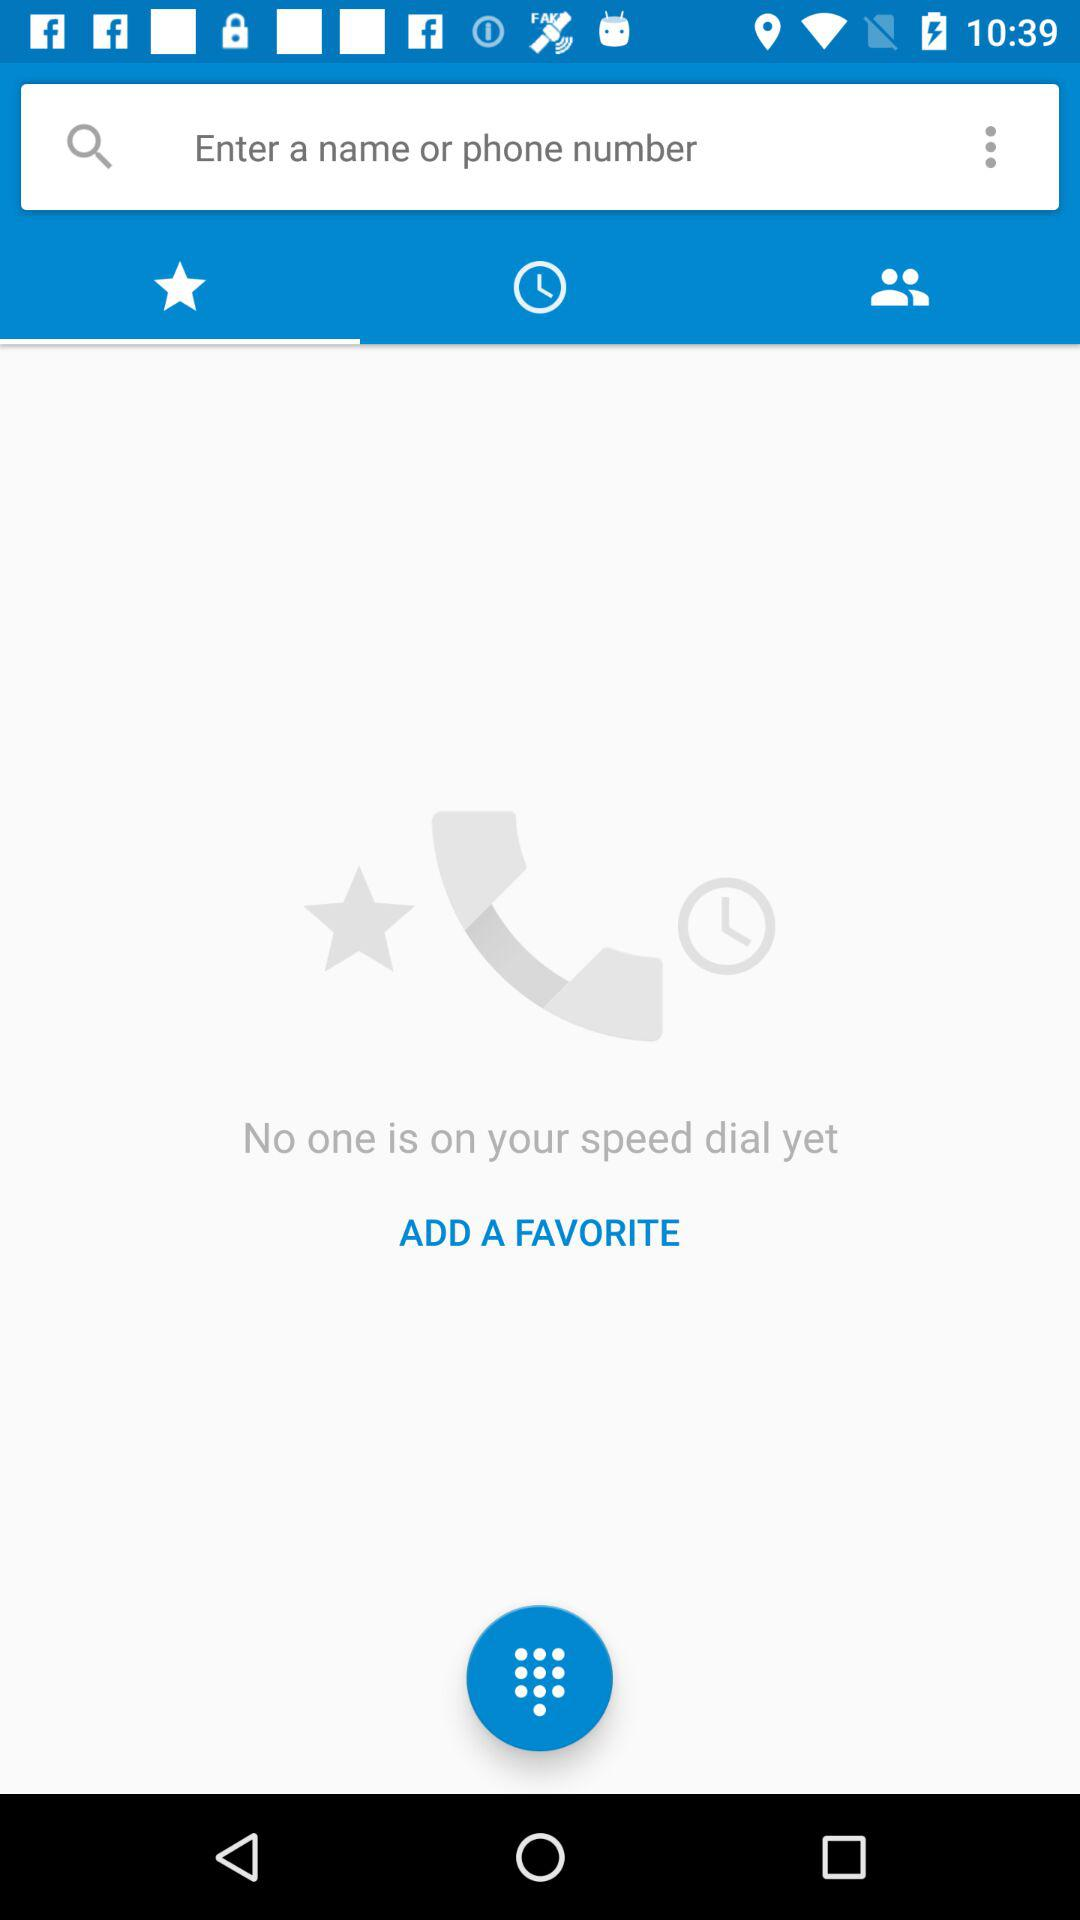Which tab has been selected? The selected tab is "Favorites". 